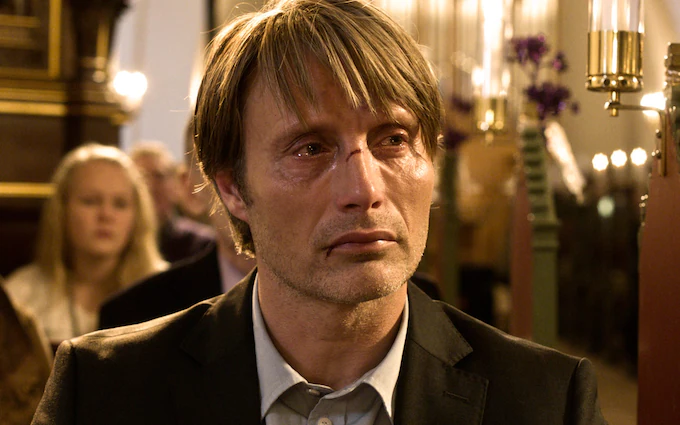Imagine that the man in the image could speak. What might he say right now? If the man in the image could speak, he might express his feelings of regret or sorrow. He might say something like, 'I never thought it would come to this. Everything I held dear is slipping away, and I don't know how to hold on anymore.' This hypothetical statement captures the visible agony and contemplation on his face, resonating with the emotional weight of the scene. 